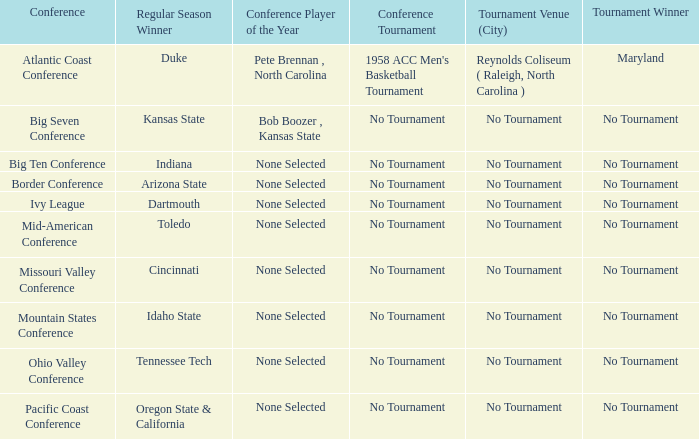Who won the tournament when Idaho State won the regular season? No Tournament. 